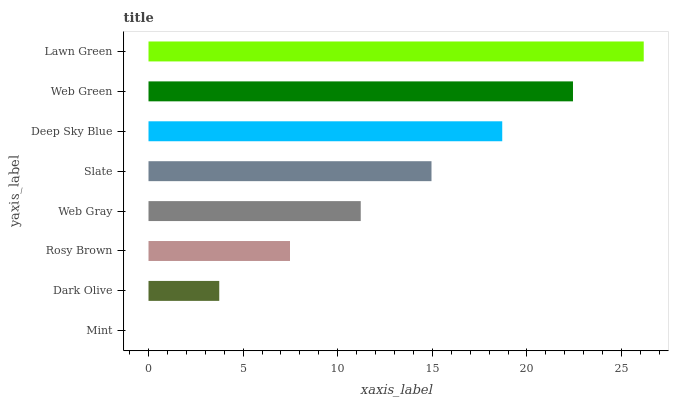Is Mint the minimum?
Answer yes or no. Yes. Is Lawn Green the maximum?
Answer yes or no. Yes. Is Dark Olive the minimum?
Answer yes or no. No. Is Dark Olive the maximum?
Answer yes or no. No. Is Dark Olive greater than Mint?
Answer yes or no. Yes. Is Mint less than Dark Olive?
Answer yes or no. Yes. Is Mint greater than Dark Olive?
Answer yes or no. No. Is Dark Olive less than Mint?
Answer yes or no. No. Is Slate the high median?
Answer yes or no. Yes. Is Web Gray the low median?
Answer yes or no. Yes. Is Deep Sky Blue the high median?
Answer yes or no. No. Is Dark Olive the low median?
Answer yes or no. No. 